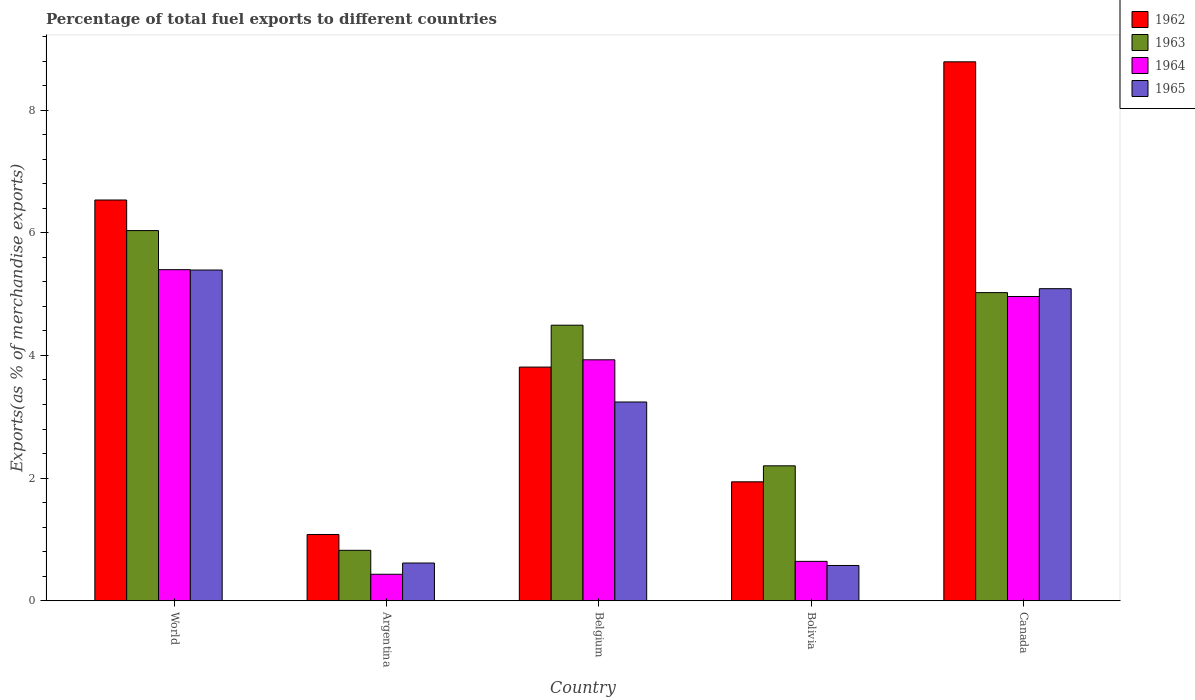Are the number of bars per tick equal to the number of legend labels?
Ensure brevity in your answer.  Yes. Are the number of bars on each tick of the X-axis equal?
Your answer should be compact. Yes. How many bars are there on the 4th tick from the left?
Make the answer very short. 4. How many bars are there on the 3rd tick from the right?
Provide a succinct answer. 4. What is the label of the 4th group of bars from the left?
Provide a short and direct response. Bolivia. What is the percentage of exports to different countries in 1965 in Canada?
Keep it short and to the point. 5.09. Across all countries, what is the maximum percentage of exports to different countries in 1964?
Offer a very short reply. 5.4. Across all countries, what is the minimum percentage of exports to different countries in 1964?
Your answer should be very brief. 0.43. In which country was the percentage of exports to different countries in 1964 minimum?
Offer a very short reply. Argentina. What is the total percentage of exports to different countries in 1962 in the graph?
Offer a terse response. 22.15. What is the difference between the percentage of exports to different countries in 1963 in Argentina and that in Bolivia?
Your answer should be very brief. -1.38. What is the difference between the percentage of exports to different countries in 1965 in World and the percentage of exports to different countries in 1962 in Bolivia?
Keep it short and to the point. 3.45. What is the average percentage of exports to different countries in 1963 per country?
Your response must be concise. 3.72. What is the difference between the percentage of exports to different countries of/in 1964 and percentage of exports to different countries of/in 1965 in Argentina?
Ensure brevity in your answer.  -0.18. In how many countries, is the percentage of exports to different countries in 1962 greater than 8.8 %?
Your answer should be compact. 0. What is the ratio of the percentage of exports to different countries in 1965 in Argentina to that in Bolivia?
Ensure brevity in your answer.  1.07. What is the difference between the highest and the second highest percentage of exports to different countries in 1962?
Provide a short and direct response. 4.98. What is the difference between the highest and the lowest percentage of exports to different countries in 1963?
Ensure brevity in your answer.  5.21. In how many countries, is the percentage of exports to different countries in 1964 greater than the average percentage of exports to different countries in 1964 taken over all countries?
Provide a succinct answer. 3. Is the sum of the percentage of exports to different countries in 1964 in Bolivia and Canada greater than the maximum percentage of exports to different countries in 1965 across all countries?
Your answer should be compact. Yes. Is it the case that in every country, the sum of the percentage of exports to different countries in 1965 and percentage of exports to different countries in 1962 is greater than the sum of percentage of exports to different countries in 1964 and percentage of exports to different countries in 1963?
Offer a very short reply. Yes. What does the 1st bar from the left in Canada represents?
Provide a short and direct response. 1962. Is it the case that in every country, the sum of the percentage of exports to different countries in 1964 and percentage of exports to different countries in 1965 is greater than the percentage of exports to different countries in 1963?
Your answer should be very brief. No. What is the difference between two consecutive major ticks on the Y-axis?
Provide a short and direct response. 2. Are the values on the major ticks of Y-axis written in scientific E-notation?
Give a very brief answer. No. How are the legend labels stacked?
Provide a succinct answer. Vertical. What is the title of the graph?
Your answer should be compact. Percentage of total fuel exports to different countries. Does "1968" appear as one of the legend labels in the graph?
Offer a terse response. No. What is the label or title of the X-axis?
Provide a succinct answer. Country. What is the label or title of the Y-axis?
Keep it short and to the point. Exports(as % of merchandise exports). What is the Exports(as % of merchandise exports) in 1962 in World?
Your response must be concise. 6.53. What is the Exports(as % of merchandise exports) in 1963 in World?
Your answer should be compact. 6.04. What is the Exports(as % of merchandise exports) in 1964 in World?
Your response must be concise. 5.4. What is the Exports(as % of merchandise exports) in 1965 in World?
Offer a very short reply. 5.39. What is the Exports(as % of merchandise exports) in 1962 in Argentina?
Your answer should be compact. 1.08. What is the Exports(as % of merchandise exports) of 1963 in Argentina?
Make the answer very short. 0.82. What is the Exports(as % of merchandise exports) in 1964 in Argentina?
Ensure brevity in your answer.  0.43. What is the Exports(as % of merchandise exports) of 1965 in Argentina?
Make the answer very short. 0.62. What is the Exports(as % of merchandise exports) in 1962 in Belgium?
Your response must be concise. 3.81. What is the Exports(as % of merchandise exports) of 1963 in Belgium?
Your response must be concise. 4.49. What is the Exports(as % of merchandise exports) in 1964 in Belgium?
Keep it short and to the point. 3.93. What is the Exports(as % of merchandise exports) in 1965 in Belgium?
Your answer should be compact. 3.24. What is the Exports(as % of merchandise exports) of 1962 in Bolivia?
Ensure brevity in your answer.  1.94. What is the Exports(as % of merchandise exports) of 1963 in Bolivia?
Make the answer very short. 2.2. What is the Exports(as % of merchandise exports) of 1964 in Bolivia?
Your response must be concise. 0.64. What is the Exports(as % of merchandise exports) in 1965 in Bolivia?
Provide a succinct answer. 0.58. What is the Exports(as % of merchandise exports) of 1962 in Canada?
Keep it short and to the point. 8.79. What is the Exports(as % of merchandise exports) in 1963 in Canada?
Your response must be concise. 5.02. What is the Exports(as % of merchandise exports) in 1964 in Canada?
Offer a very short reply. 4.96. What is the Exports(as % of merchandise exports) of 1965 in Canada?
Your answer should be very brief. 5.09. Across all countries, what is the maximum Exports(as % of merchandise exports) in 1962?
Your answer should be compact. 8.79. Across all countries, what is the maximum Exports(as % of merchandise exports) of 1963?
Keep it short and to the point. 6.04. Across all countries, what is the maximum Exports(as % of merchandise exports) of 1964?
Give a very brief answer. 5.4. Across all countries, what is the maximum Exports(as % of merchandise exports) of 1965?
Your answer should be compact. 5.39. Across all countries, what is the minimum Exports(as % of merchandise exports) in 1962?
Give a very brief answer. 1.08. Across all countries, what is the minimum Exports(as % of merchandise exports) in 1963?
Give a very brief answer. 0.82. Across all countries, what is the minimum Exports(as % of merchandise exports) in 1964?
Your answer should be compact. 0.43. Across all countries, what is the minimum Exports(as % of merchandise exports) of 1965?
Your response must be concise. 0.58. What is the total Exports(as % of merchandise exports) in 1962 in the graph?
Offer a terse response. 22.15. What is the total Exports(as % of merchandise exports) in 1963 in the graph?
Provide a short and direct response. 18.58. What is the total Exports(as % of merchandise exports) in 1964 in the graph?
Your response must be concise. 15.36. What is the total Exports(as % of merchandise exports) of 1965 in the graph?
Keep it short and to the point. 14.91. What is the difference between the Exports(as % of merchandise exports) of 1962 in World and that in Argentina?
Ensure brevity in your answer.  5.45. What is the difference between the Exports(as % of merchandise exports) in 1963 in World and that in Argentina?
Provide a succinct answer. 5.21. What is the difference between the Exports(as % of merchandise exports) of 1964 in World and that in Argentina?
Your response must be concise. 4.97. What is the difference between the Exports(as % of merchandise exports) of 1965 in World and that in Argentina?
Offer a terse response. 4.78. What is the difference between the Exports(as % of merchandise exports) in 1962 in World and that in Belgium?
Ensure brevity in your answer.  2.72. What is the difference between the Exports(as % of merchandise exports) of 1963 in World and that in Belgium?
Your response must be concise. 1.54. What is the difference between the Exports(as % of merchandise exports) in 1964 in World and that in Belgium?
Your response must be concise. 1.47. What is the difference between the Exports(as % of merchandise exports) of 1965 in World and that in Belgium?
Provide a short and direct response. 2.15. What is the difference between the Exports(as % of merchandise exports) of 1962 in World and that in Bolivia?
Offer a very short reply. 4.59. What is the difference between the Exports(as % of merchandise exports) of 1963 in World and that in Bolivia?
Your answer should be very brief. 3.84. What is the difference between the Exports(as % of merchandise exports) of 1964 in World and that in Bolivia?
Give a very brief answer. 4.76. What is the difference between the Exports(as % of merchandise exports) in 1965 in World and that in Bolivia?
Your answer should be very brief. 4.82. What is the difference between the Exports(as % of merchandise exports) of 1962 in World and that in Canada?
Offer a terse response. -2.25. What is the difference between the Exports(as % of merchandise exports) in 1963 in World and that in Canada?
Offer a very short reply. 1.01. What is the difference between the Exports(as % of merchandise exports) in 1964 in World and that in Canada?
Your response must be concise. 0.44. What is the difference between the Exports(as % of merchandise exports) of 1965 in World and that in Canada?
Provide a short and direct response. 0.3. What is the difference between the Exports(as % of merchandise exports) of 1962 in Argentina and that in Belgium?
Offer a very short reply. -2.73. What is the difference between the Exports(as % of merchandise exports) in 1963 in Argentina and that in Belgium?
Your response must be concise. -3.67. What is the difference between the Exports(as % of merchandise exports) in 1964 in Argentina and that in Belgium?
Your response must be concise. -3.5. What is the difference between the Exports(as % of merchandise exports) in 1965 in Argentina and that in Belgium?
Your response must be concise. -2.63. What is the difference between the Exports(as % of merchandise exports) of 1962 in Argentina and that in Bolivia?
Offer a very short reply. -0.86. What is the difference between the Exports(as % of merchandise exports) of 1963 in Argentina and that in Bolivia?
Keep it short and to the point. -1.38. What is the difference between the Exports(as % of merchandise exports) in 1964 in Argentina and that in Bolivia?
Ensure brevity in your answer.  -0.21. What is the difference between the Exports(as % of merchandise exports) in 1965 in Argentina and that in Bolivia?
Ensure brevity in your answer.  0.04. What is the difference between the Exports(as % of merchandise exports) in 1962 in Argentina and that in Canada?
Offer a terse response. -7.71. What is the difference between the Exports(as % of merchandise exports) of 1963 in Argentina and that in Canada?
Your answer should be compact. -4.2. What is the difference between the Exports(as % of merchandise exports) of 1964 in Argentina and that in Canada?
Keep it short and to the point. -4.53. What is the difference between the Exports(as % of merchandise exports) of 1965 in Argentina and that in Canada?
Provide a short and direct response. -4.47. What is the difference between the Exports(as % of merchandise exports) in 1962 in Belgium and that in Bolivia?
Make the answer very short. 1.87. What is the difference between the Exports(as % of merchandise exports) of 1963 in Belgium and that in Bolivia?
Give a very brief answer. 2.29. What is the difference between the Exports(as % of merchandise exports) in 1964 in Belgium and that in Bolivia?
Keep it short and to the point. 3.29. What is the difference between the Exports(as % of merchandise exports) in 1965 in Belgium and that in Bolivia?
Offer a very short reply. 2.67. What is the difference between the Exports(as % of merchandise exports) in 1962 in Belgium and that in Canada?
Give a very brief answer. -4.98. What is the difference between the Exports(as % of merchandise exports) in 1963 in Belgium and that in Canada?
Give a very brief answer. -0.53. What is the difference between the Exports(as % of merchandise exports) of 1964 in Belgium and that in Canada?
Make the answer very short. -1.03. What is the difference between the Exports(as % of merchandise exports) in 1965 in Belgium and that in Canada?
Provide a succinct answer. -1.85. What is the difference between the Exports(as % of merchandise exports) in 1962 in Bolivia and that in Canada?
Provide a short and direct response. -6.85. What is the difference between the Exports(as % of merchandise exports) of 1963 in Bolivia and that in Canada?
Your response must be concise. -2.82. What is the difference between the Exports(as % of merchandise exports) in 1964 in Bolivia and that in Canada?
Give a very brief answer. -4.32. What is the difference between the Exports(as % of merchandise exports) in 1965 in Bolivia and that in Canada?
Your answer should be compact. -4.51. What is the difference between the Exports(as % of merchandise exports) of 1962 in World and the Exports(as % of merchandise exports) of 1963 in Argentina?
Offer a terse response. 5.71. What is the difference between the Exports(as % of merchandise exports) of 1962 in World and the Exports(as % of merchandise exports) of 1964 in Argentina?
Keep it short and to the point. 6.1. What is the difference between the Exports(as % of merchandise exports) in 1962 in World and the Exports(as % of merchandise exports) in 1965 in Argentina?
Offer a terse response. 5.92. What is the difference between the Exports(as % of merchandise exports) of 1963 in World and the Exports(as % of merchandise exports) of 1964 in Argentina?
Offer a terse response. 5.6. What is the difference between the Exports(as % of merchandise exports) in 1963 in World and the Exports(as % of merchandise exports) in 1965 in Argentina?
Give a very brief answer. 5.42. What is the difference between the Exports(as % of merchandise exports) in 1964 in World and the Exports(as % of merchandise exports) in 1965 in Argentina?
Your answer should be compact. 4.78. What is the difference between the Exports(as % of merchandise exports) of 1962 in World and the Exports(as % of merchandise exports) of 1963 in Belgium?
Your answer should be very brief. 2.04. What is the difference between the Exports(as % of merchandise exports) in 1962 in World and the Exports(as % of merchandise exports) in 1964 in Belgium?
Keep it short and to the point. 2.61. What is the difference between the Exports(as % of merchandise exports) in 1962 in World and the Exports(as % of merchandise exports) in 1965 in Belgium?
Provide a succinct answer. 3.29. What is the difference between the Exports(as % of merchandise exports) of 1963 in World and the Exports(as % of merchandise exports) of 1964 in Belgium?
Offer a very short reply. 2.11. What is the difference between the Exports(as % of merchandise exports) in 1963 in World and the Exports(as % of merchandise exports) in 1965 in Belgium?
Keep it short and to the point. 2.79. What is the difference between the Exports(as % of merchandise exports) of 1964 in World and the Exports(as % of merchandise exports) of 1965 in Belgium?
Offer a terse response. 2.16. What is the difference between the Exports(as % of merchandise exports) of 1962 in World and the Exports(as % of merchandise exports) of 1963 in Bolivia?
Ensure brevity in your answer.  4.33. What is the difference between the Exports(as % of merchandise exports) of 1962 in World and the Exports(as % of merchandise exports) of 1964 in Bolivia?
Offer a terse response. 5.89. What is the difference between the Exports(as % of merchandise exports) of 1962 in World and the Exports(as % of merchandise exports) of 1965 in Bolivia?
Provide a short and direct response. 5.96. What is the difference between the Exports(as % of merchandise exports) in 1963 in World and the Exports(as % of merchandise exports) in 1964 in Bolivia?
Your answer should be compact. 5.39. What is the difference between the Exports(as % of merchandise exports) in 1963 in World and the Exports(as % of merchandise exports) in 1965 in Bolivia?
Your answer should be compact. 5.46. What is the difference between the Exports(as % of merchandise exports) in 1964 in World and the Exports(as % of merchandise exports) in 1965 in Bolivia?
Give a very brief answer. 4.82. What is the difference between the Exports(as % of merchandise exports) in 1962 in World and the Exports(as % of merchandise exports) in 1963 in Canada?
Keep it short and to the point. 1.51. What is the difference between the Exports(as % of merchandise exports) of 1962 in World and the Exports(as % of merchandise exports) of 1964 in Canada?
Provide a succinct answer. 1.57. What is the difference between the Exports(as % of merchandise exports) of 1962 in World and the Exports(as % of merchandise exports) of 1965 in Canada?
Give a very brief answer. 1.45. What is the difference between the Exports(as % of merchandise exports) in 1963 in World and the Exports(as % of merchandise exports) in 1964 in Canada?
Give a very brief answer. 1.07. What is the difference between the Exports(as % of merchandise exports) in 1963 in World and the Exports(as % of merchandise exports) in 1965 in Canada?
Your response must be concise. 0.95. What is the difference between the Exports(as % of merchandise exports) of 1964 in World and the Exports(as % of merchandise exports) of 1965 in Canada?
Provide a succinct answer. 0.31. What is the difference between the Exports(as % of merchandise exports) in 1962 in Argentina and the Exports(as % of merchandise exports) in 1963 in Belgium?
Ensure brevity in your answer.  -3.41. What is the difference between the Exports(as % of merchandise exports) of 1962 in Argentina and the Exports(as % of merchandise exports) of 1964 in Belgium?
Keep it short and to the point. -2.85. What is the difference between the Exports(as % of merchandise exports) of 1962 in Argentina and the Exports(as % of merchandise exports) of 1965 in Belgium?
Ensure brevity in your answer.  -2.16. What is the difference between the Exports(as % of merchandise exports) in 1963 in Argentina and the Exports(as % of merchandise exports) in 1964 in Belgium?
Offer a terse response. -3.11. What is the difference between the Exports(as % of merchandise exports) in 1963 in Argentina and the Exports(as % of merchandise exports) in 1965 in Belgium?
Your answer should be compact. -2.42. What is the difference between the Exports(as % of merchandise exports) of 1964 in Argentina and the Exports(as % of merchandise exports) of 1965 in Belgium?
Your answer should be very brief. -2.81. What is the difference between the Exports(as % of merchandise exports) of 1962 in Argentina and the Exports(as % of merchandise exports) of 1963 in Bolivia?
Provide a short and direct response. -1.12. What is the difference between the Exports(as % of merchandise exports) in 1962 in Argentina and the Exports(as % of merchandise exports) in 1964 in Bolivia?
Offer a very short reply. 0.44. What is the difference between the Exports(as % of merchandise exports) of 1962 in Argentina and the Exports(as % of merchandise exports) of 1965 in Bolivia?
Your response must be concise. 0.51. What is the difference between the Exports(as % of merchandise exports) in 1963 in Argentina and the Exports(as % of merchandise exports) in 1964 in Bolivia?
Ensure brevity in your answer.  0.18. What is the difference between the Exports(as % of merchandise exports) in 1963 in Argentina and the Exports(as % of merchandise exports) in 1965 in Bolivia?
Make the answer very short. 0.25. What is the difference between the Exports(as % of merchandise exports) of 1964 in Argentina and the Exports(as % of merchandise exports) of 1965 in Bolivia?
Offer a very short reply. -0.14. What is the difference between the Exports(as % of merchandise exports) in 1962 in Argentina and the Exports(as % of merchandise exports) in 1963 in Canada?
Offer a terse response. -3.94. What is the difference between the Exports(as % of merchandise exports) in 1962 in Argentina and the Exports(as % of merchandise exports) in 1964 in Canada?
Provide a succinct answer. -3.88. What is the difference between the Exports(as % of merchandise exports) in 1962 in Argentina and the Exports(as % of merchandise exports) in 1965 in Canada?
Make the answer very short. -4.01. What is the difference between the Exports(as % of merchandise exports) of 1963 in Argentina and the Exports(as % of merchandise exports) of 1964 in Canada?
Your answer should be compact. -4.14. What is the difference between the Exports(as % of merchandise exports) in 1963 in Argentina and the Exports(as % of merchandise exports) in 1965 in Canada?
Make the answer very short. -4.27. What is the difference between the Exports(as % of merchandise exports) in 1964 in Argentina and the Exports(as % of merchandise exports) in 1965 in Canada?
Offer a terse response. -4.66. What is the difference between the Exports(as % of merchandise exports) of 1962 in Belgium and the Exports(as % of merchandise exports) of 1963 in Bolivia?
Give a very brief answer. 1.61. What is the difference between the Exports(as % of merchandise exports) of 1962 in Belgium and the Exports(as % of merchandise exports) of 1964 in Bolivia?
Give a very brief answer. 3.17. What is the difference between the Exports(as % of merchandise exports) in 1962 in Belgium and the Exports(as % of merchandise exports) in 1965 in Bolivia?
Your response must be concise. 3.23. What is the difference between the Exports(as % of merchandise exports) in 1963 in Belgium and the Exports(as % of merchandise exports) in 1964 in Bolivia?
Offer a terse response. 3.85. What is the difference between the Exports(as % of merchandise exports) of 1963 in Belgium and the Exports(as % of merchandise exports) of 1965 in Bolivia?
Your answer should be compact. 3.92. What is the difference between the Exports(as % of merchandise exports) of 1964 in Belgium and the Exports(as % of merchandise exports) of 1965 in Bolivia?
Keep it short and to the point. 3.35. What is the difference between the Exports(as % of merchandise exports) in 1962 in Belgium and the Exports(as % of merchandise exports) in 1963 in Canada?
Keep it short and to the point. -1.21. What is the difference between the Exports(as % of merchandise exports) of 1962 in Belgium and the Exports(as % of merchandise exports) of 1964 in Canada?
Offer a terse response. -1.15. What is the difference between the Exports(as % of merchandise exports) of 1962 in Belgium and the Exports(as % of merchandise exports) of 1965 in Canada?
Provide a short and direct response. -1.28. What is the difference between the Exports(as % of merchandise exports) in 1963 in Belgium and the Exports(as % of merchandise exports) in 1964 in Canada?
Provide a succinct answer. -0.47. What is the difference between the Exports(as % of merchandise exports) of 1963 in Belgium and the Exports(as % of merchandise exports) of 1965 in Canada?
Ensure brevity in your answer.  -0.6. What is the difference between the Exports(as % of merchandise exports) of 1964 in Belgium and the Exports(as % of merchandise exports) of 1965 in Canada?
Your answer should be very brief. -1.16. What is the difference between the Exports(as % of merchandise exports) of 1962 in Bolivia and the Exports(as % of merchandise exports) of 1963 in Canada?
Keep it short and to the point. -3.08. What is the difference between the Exports(as % of merchandise exports) in 1962 in Bolivia and the Exports(as % of merchandise exports) in 1964 in Canada?
Your answer should be very brief. -3.02. What is the difference between the Exports(as % of merchandise exports) of 1962 in Bolivia and the Exports(as % of merchandise exports) of 1965 in Canada?
Make the answer very short. -3.15. What is the difference between the Exports(as % of merchandise exports) of 1963 in Bolivia and the Exports(as % of merchandise exports) of 1964 in Canada?
Offer a very short reply. -2.76. What is the difference between the Exports(as % of merchandise exports) in 1963 in Bolivia and the Exports(as % of merchandise exports) in 1965 in Canada?
Keep it short and to the point. -2.89. What is the difference between the Exports(as % of merchandise exports) of 1964 in Bolivia and the Exports(as % of merchandise exports) of 1965 in Canada?
Give a very brief answer. -4.45. What is the average Exports(as % of merchandise exports) of 1962 per country?
Provide a short and direct response. 4.43. What is the average Exports(as % of merchandise exports) in 1963 per country?
Your answer should be very brief. 3.72. What is the average Exports(as % of merchandise exports) of 1964 per country?
Give a very brief answer. 3.07. What is the average Exports(as % of merchandise exports) of 1965 per country?
Make the answer very short. 2.98. What is the difference between the Exports(as % of merchandise exports) in 1962 and Exports(as % of merchandise exports) in 1963 in World?
Provide a short and direct response. 0.5. What is the difference between the Exports(as % of merchandise exports) of 1962 and Exports(as % of merchandise exports) of 1964 in World?
Make the answer very short. 1.14. What is the difference between the Exports(as % of merchandise exports) of 1962 and Exports(as % of merchandise exports) of 1965 in World?
Keep it short and to the point. 1.14. What is the difference between the Exports(as % of merchandise exports) in 1963 and Exports(as % of merchandise exports) in 1964 in World?
Keep it short and to the point. 0.64. What is the difference between the Exports(as % of merchandise exports) of 1963 and Exports(as % of merchandise exports) of 1965 in World?
Give a very brief answer. 0.64. What is the difference between the Exports(as % of merchandise exports) in 1964 and Exports(as % of merchandise exports) in 1965 in World?
Provide a succinct answer. 0.01. What is the difference between the Exports(as % of merchandise exports) of 1962 and Exports(as % of merchandise exports) of 1963 in Argentina?
Your answer should be compact. 0.26. What is the difference between the Exports(as % of merchandise exports) in 1962 and Exports(as % of merchandise exports) in 1964 in Argentina?
Provide a short and direct response. 0.65. What is the difference between the Exports(as % of merchandise exports) in 1962 and Exports(as % of merchandise exports) in 1965 in Argentina?
Keep it short and to the point. 0.47. What is the difference between the Exports(as % of merchandise exports) of 1963 and Exports(as % of merchandise exports) of 1964 in Argentina?
Provide a short and direct response. 0.39. What is the difference between the Exports(as % of merchandise exports) of 1963 and Exports(as % of merchandise exports) of 1965 in Argentina?
Your response must be concise. 0.21. What is the difference between the Exports(as % of merchandise exports) in 1964 and Exports(as % of merchandise exports) in 1965 in Argentina?
Give a very brief answer. -0.18. What is the difference between the Exports(as % of merchandise exports) in 1962 and Exports(as % of merchandise exports) in 1963 in Belgium?
Provide a succinct answer. -0.68. What is the difference between the Exports(as % of merchandise exports) of 1962 and Exports(as % of merchandise exports) of 1964 in Belgium?
Provide a short and direct response. -0.12. What is the difference between the Exports(as % of merchandise exports) in 1962 and Exports(as % of merchandise exports) in 1965 in Belgium?
Give a very brief answer. 0.57. What is the difference between the Exports(as % of merchandise exports) of 1963 and Exports(as % of merchandise exports) of 1964 in Belgium?
Provide a short and direct response. 0.56. What is the difference between the Exports(as % of merchandise exports) of 1963 and Exports(as % of merchandise exports) of 1965 in Belgium?
Ensure brevity in your answer.  1.25. What is the difference between the Exports(as % of merchandise exports) of 1964 and Exports(as % of merchandise exports) of 1965 in Belgium?
Offer a very short reply. 0.69. What is the difference between the Exports(as % of merchandise exports) in 1962 and Exports(as % of merchandise exports) in 1963 in Bolivia?
Keep it short and to the point. -0.26. What is the difference between the Exports(as % of merchandise exports) in 1962 and Exports(as % of merchandise exports) in 1964 in Bolivia?
Provide a short and direct response. 1.3. What is the difference between the Exports(as % of merchandise exports) in 1962 and Exports(as % of merchandise exports) in 1965 in Bolivia?
Provide a succinct answer. 1.36. What is the difference between the Exports(as % of merchandise exports) of 1963 and Exports(as % of merchandise exports) of 1964 in Bolivia?
Give a very brief answer. 1.56. What is the difference between the Exports(as % of merchandise exports) in 1963 and Exports(as % of merchandise exports) in 1965 in Bolivia?
Keep it short and to the point. 1.62. What is the difference between the Exports(as % of merchandise exports) of 1964 and Exports(as % of merchandise exports) of 1965 in Bolivia?
Give a very brief answer. 0.07. What is the difference between the Exports(as % of merchandise exports) in 1962 and Exports(as % of merchandise exports) in 1963 in Canada?
Offer a very short reply. 3.76. What is the difference between the Exports(as % of merchandise exports) in 1962 and Exports(as % of merchandise exports) in 1964 in Canada?
Make the answer very short. 3.83. What is the difference between the Exports(as % of merchandise exports) in 1962 and Exports(as % of merchandise exports) in 1965 in Canada?
Offer a terse response. 3.7. What is the difference between the Exports(as % of merchandise exports) of 1963 and Exports(as % of merchandise exports) of 1964 in Canada?
Ensure brevity in your answer.  0.06. What is the difference between the Exports(as % of merchandise exports) in 1963 and Exports(as % of merchandise exports) in 1965 in Canada?
Your answer should be very brief. -0.06. What is the difference between the Exports(as % of merchandise exports) in 1964 and Exports(as % of merchandise exports) in 1965 in Canada?
Your answer should be compact. -0.13. What is the ratio of the Exports(as % of merchandise exports) in 1962 in World to that in Argentina?
Keep it short and to the point. 6.05. What is the ratio of the Exports(as % of merchandise exports) in 1963 in World to that in Argentina?
Provide a short and direct response. 7.34. What is the ratio of the Exports(as % of merchandise exports) in 1964 in World to that in Argentina?
Make the answer very short. 12.49. What is the ratio of the Exports(as % of merchandise exports) of 1965 in World to that in Argentina?
Give a very brief answer. 8.76. What is the ratio of the Exports(as % of merchandise exports) of 1962 in World to that in Belgium?
Offer a very short reply. 1.72. What is the ratio of the Exports(as % of merchandise exports) in 1963 in World to that in Belgium?
Provide a short and direct response. 1.34. What is the ratio of the Exports(as % of merchandise exports) in 1964 in World to that in Belgium?
Offer a very short reply. 1.37. What is the ratio of the Exports(as % of merchandise exports) of 1965 in World to that in Belgium?
Your answer should be compact. 1.66. What is the ratio of the Exports(as % of merchandise exports) in 1962 in World to that in Bolivia?
Keep it short and to the point. 3.37. What is the ratio of the Exports(as % of merchandise exports) of 1963 in World to that in Bolivia?
Keep it short and to the point. 2.74. What is the ratio of the Exports(as % of merchandise exports) in 1964 in World to that in Bolivia?
Ensure brevity in your answer.  8.4. What is the ratio of the Exports(as % of merchandise exports) of 1965 in World to that in Bolivia?
Ensure brevity in your answer.  9.37. What is the ratio of the Exports(as % of merchandise exports) of 1962 in World to that in Canada?
Your answer should be compact. 0.74. What is the ratio of the Exports(as % of merchandise exports) of 1963 in World to that in Canada?
Give a very brief answer. 1.2. What is the ratio of the Exports(as % of merchandise exports) of 1964 in World to that in Canada?
Offer a very short reply. 1.09. What is the ratio of the Exports(as % of merchandise exports) in 1965 in World to that in Canada?
Provide a short and direct response. 1.06. What is the ratio of the Exports(as % of merchandise exports) in 1962 in Argentina to that in Belgium?
Your response must be concise. 0.28. What is the ratio of the Exports(as % of merchandise exports) of 1963 in Argentina to that in Belgium?
Your response must be concise. 0.18. What is the ratio of the Exports(as % of merchandise exports) of 1964 in Argentina to that in Belgium?
Give a very brief answer. 0.11. What is the ratio of the Exports(as % of merchandise exports) of 1965 in Argentina to that in Belgium?
Your answer should be very brief. 0.19. What is the ratio of the Exports(as % of merchandise exports) of 1962 in Argentina to that in Bolivia?
Provide a succinct answer. 0.56. What is the ratio of the Exports(as % of merchandise exports) in 1963 in Argentina to that in Bolivia?
Your answer should be compact. 0.37. What is the ratio of the Exports(as % of merchandise exports) of 1964 in Argentina to that in Bolivia?
Give a very brief answer. 0.67. What is the ratio of the Exports(as % of merchandise exports) of 1965 in Argentina to that in Bolivia?
Your answer should be very brief. 1.07. What is the ratio of the Exports(as % of merchandise exports) of 1962 in Argentina to that in Canada?
Keep it short and to the point. 0.12. What is the ratio of the Exports(as % of merchandise exports) in 1963 in Argentina to that in Canada?
Keep it short and to the point. 0.16. What is the ratio of the Exports(as % of merchandise exports) of 1964 in Argentina to that in Canada?
Your response must be concise. 0.09. What is the ratio of the Exports(as % of merchandise exports) in 1965 in Argentina to that in Canada?
Provide a short and direct response. 0.12. What is the ratio of the Exports(as % of merchandise exports) of 1962 in Belgium to that in Bolivia?
Your answer should be very brief. 1.96. What is the ratio of the Exports(as % of merchandise exports) in 1963 in Belgium to that in Bolivia?
Keep it short and to the point. 2.04. What is the ratio of the Exports(as % of merchandise exports) of 1964 in Belgium to that in Bolivia?
Provide a succinct answer. 6.12. What is the ratio of the Exports(as % of merchandise exports) in 1965 in Belgium to that in Bolivia?
Ensure brevity in your answer.  5.63. What is the ratio of the Exports(as % of merchandise exports) in 1962 in Belgium to that in Canada?
Offer a terse response. 0.43. What is the ratio of the Exports(as % of merchandise exports) of 1963 in Belgium to that in Canada?
Offer a terse response. 0.89. What is the ratio of the Exports(as % of merchandise exports) of 1964 in Belgium to that in Canada?
Provide a succinct answer. 0.79. What is the ratio of the Exports(as % of merchandise exports) in 1965 in Belgium to that in Canada?
Your response must be concise. 0.64. What is the ratio of the Exports(as % of merchandise exports) in 1962 in Bolivia to that in Canada?
Your response must be concise. 0.22. What is the ratio of the Exports(as % of merchandise exports) of 1963 in Bolivia to that in Canada?
Your response must be concise. 0.44. What is the ratio of the Exports(as % of merchandise exports) of 1964 in Bolivia to that in Canada?
Make the answer very short. 0.13. What is the ratio of the Exports(as % of merchandise exports) of 1965 in Bolivia to that in Canada?
Your answer should be very brief. 0.11. What is the difference between the highest and the second highest Exports(as % of merchandise exports) in 1962?
Ensure brevity in your answer.  2.25. What is the difference between the highest and the second highest Exports(as % of merchandise exports) in 1963?
Offer a very short reply. 1.01. What is the difference between the highest and the second highest Exports(as % of merchandise exports) in 1964?
Your answer should be compact. 0.44. What is the difference between the highest and the second highest Exports(as % of merchandise exports) of 1965?
Your response must be concise. 0.3. What is the difference between the highest and the lowest Exports(as % of merchandise exports) of 1962?
Offer a very short reply. 7.71. What is the difference between the highest and the lowest Exports(as % of merchandise exports) of 1963?
Your response must be concise. 5.21. What is the difference between the highest and the lowest Exports(as % of merchandise exports) of 1964?
Offer a very short reply. 4.97. What is the difference between the highest and the lowest Exports(as % of merchandise exports) of 1965?
Ensure brevity in your answer.  4.82. 